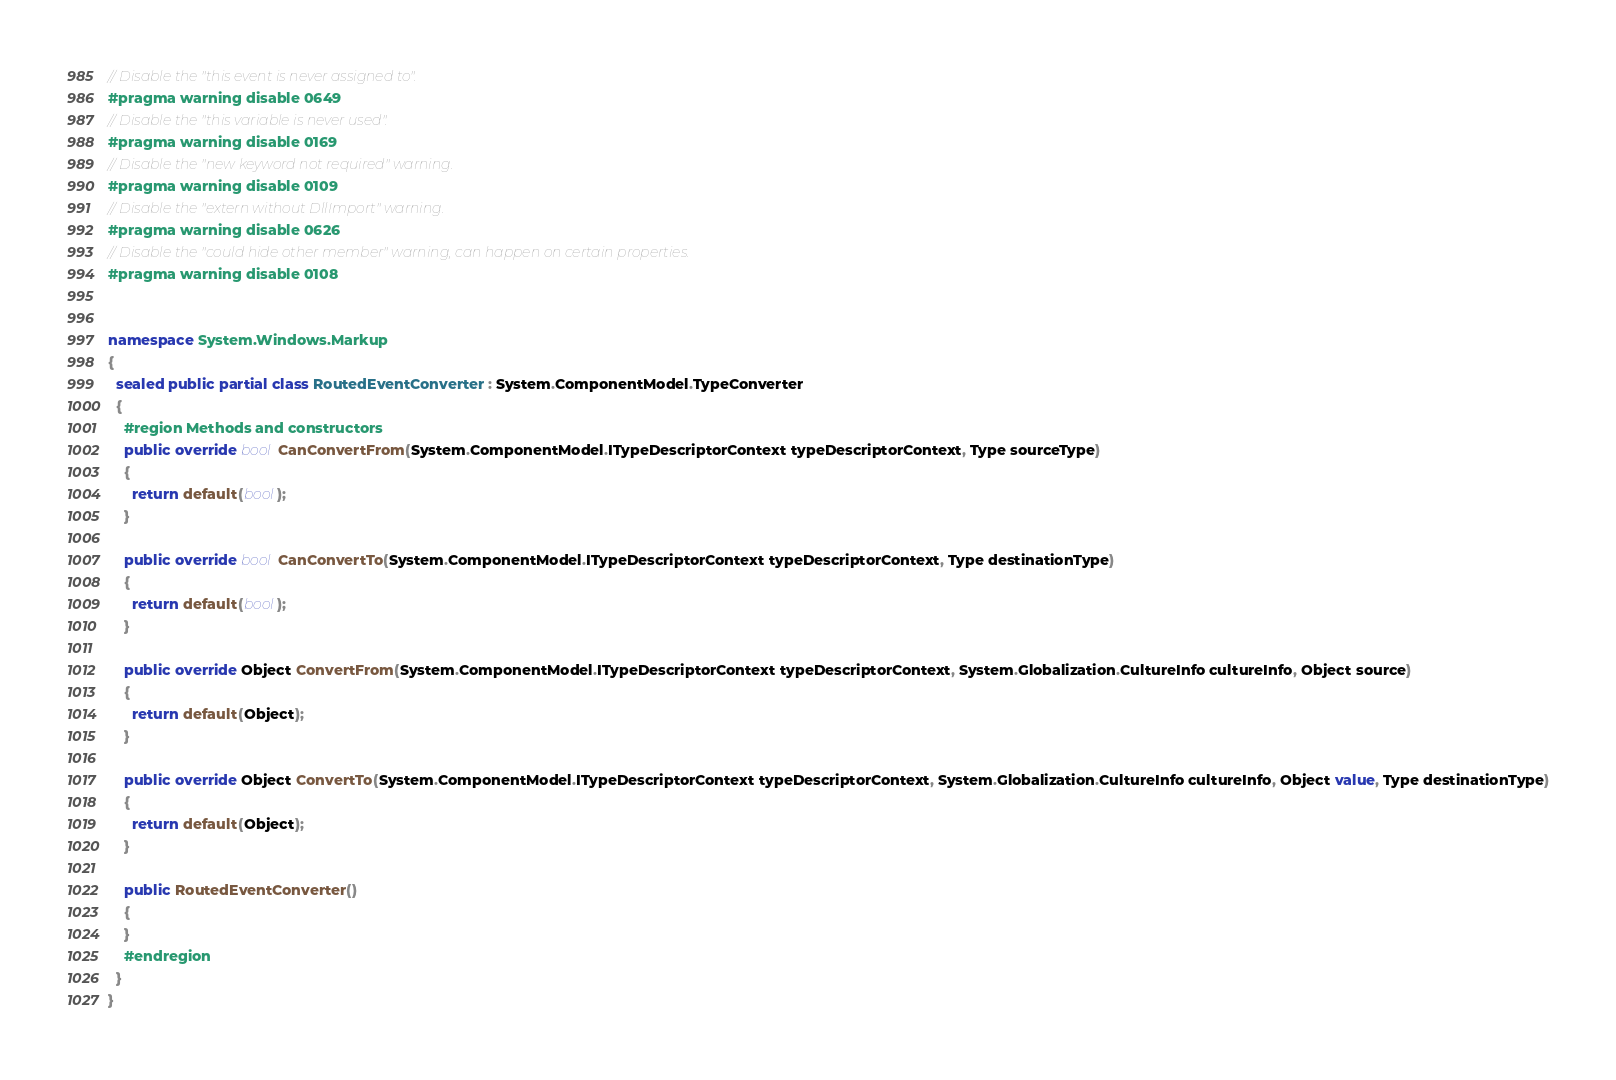Convert code to text. <code><loc_0><loc_0><loc_500><loc_500><_C#_>// Disable the "this event is never assigned to".
#pragma warning disable 0649
// Disable the "this variable is never used".
#pragma warning disable 0169
// Disable the "new keyword not required" warning.
#pragma warning disable 0109
// Disable the "extern without DllImport" warning.
#pragma warning disable 0626
// Disable the "could hide other member" warning, can happen on certain properties.
#pragma warning disable 0108


namespace System.Windows.Markup
{
  sealed public partial class RoutedEventConverter : System.ComponentModel.TypeConverter
  {
    #region Methods and constructors
    public override bool CanConvertFrom(System.ComponentModel.ITypeDescriptorContext typeDescriptorContext, Type sourceType)
    {
      return default(bool);
    }

    public override bool CanConvertTo(System.ComponentModel.ITypeDescriptorContext typeDescriptorContext, Type destinationType)
    {
      return default(bool);
    }

    public override Object ConvertFrom(System.ComponentModel.ITypeDescriptorContext typeDescriptorContext, System.Globalization.CultureInfo cultureInfo, Object source)
    {
      return default(Object);
    }

    public override Object ConvertTo(System.ComponentModel.ITypeDescriptorContext typeDescriptorContext, System.Globalization.CultureInfo cultureInfo, Object value, Type destinationType)
    {
      return default(Object);
    }

    public RoutedEventConverter()
    {
    }
    #endregion
  }
}
</code> 